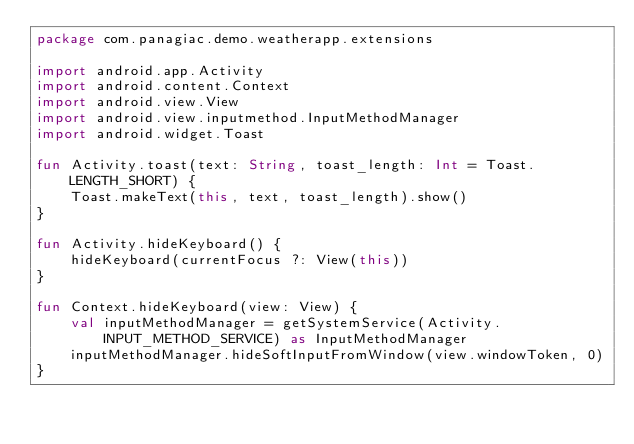Convert code to text. <code><loc_0><loc_0><loc_500><loc_500><_Kotlin_>package com.panagiac.demo.weatherapp.extensions

import android.app.Activity
import android.content.Context
import android.view.View
import android.view.inputmethod.InputMethodManager
import android.widget.Toast

fun Activity.toast(text: String, toast_length: Int = Toast.LENGTH_SHORT) {
    Toast.makeText(this, text, toast_length).show()
}

fun Activity.hideKeyboard() {
    hideKeyboard(currentFocus ?: View(this))
}

fun Context.hideKeyboard(view: View) {
    val inputMethodManager = getSystemService(Activity.INPUT_METHOD_SERVICE) as InputMethodManager
    inputMethodManager.hideSoftInputFromWindow(view.windowToken, 0)
}
</code> 